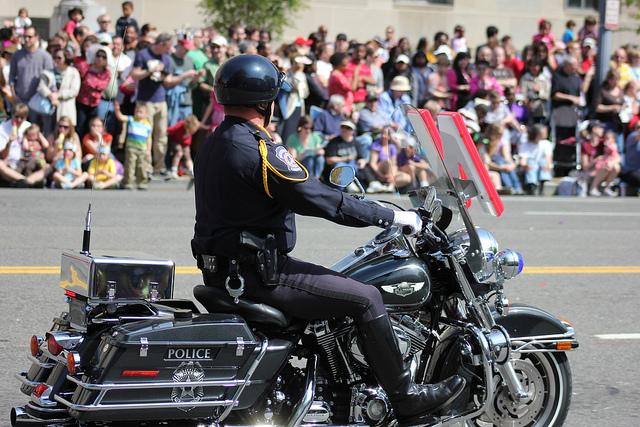What city does the motorcycle cop work in?
Write a very short answer. New york. Is he a firefighter?
Write a very short answer. No. How many bikers are wearing red?
Be succinct. 0. Is he wearing knee high boots?
Concise answer only. Yes. Is this officer armed?
Keep it brief. Yes. How many people are in the background?
Write a very short answer. 100. 